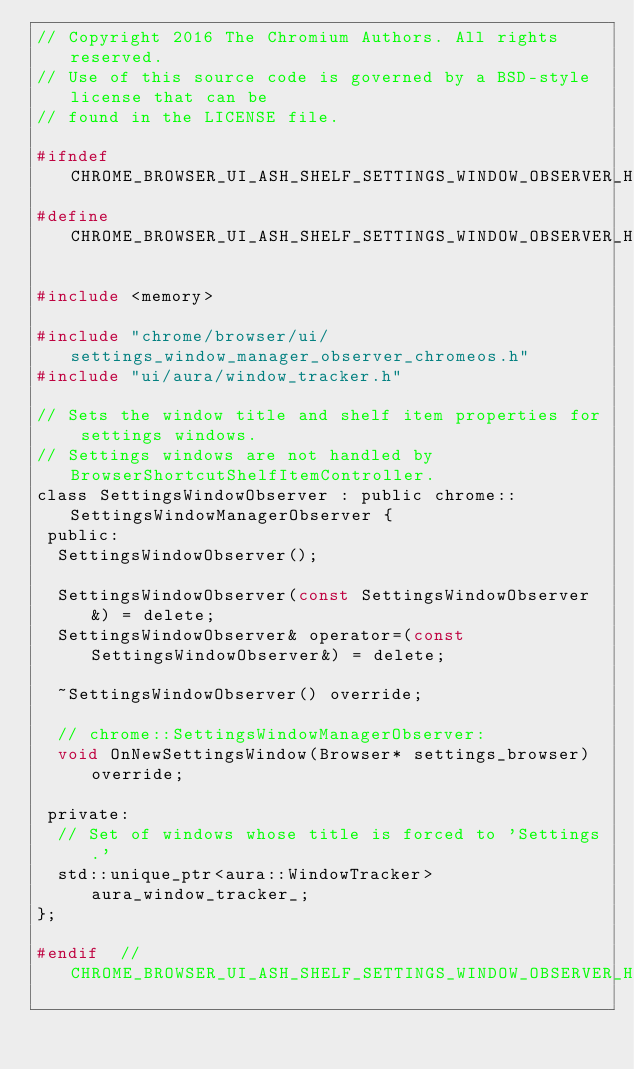Convert code to text. <code><loc_0><loc_0><loc_500><loc_500><_C_>// Copyright 2016 The Chromium Authors. All rights reserved.
// Use of this source code is governed by a BSD-style license that can be
// found in the LICENSE file.

#ifndef CHROME_BROWSER_UI_ASH_SHELF_SETTINGS_WINDOW_OBSERVER_H_
#define CHROME_BROWSER_UI_ASH_SHELF_SETTINGS_WINDOW_OBSERVER_H_

#include <memory>

#include "chrome/browser/ui/settings_window_manager_observer_chromeos.h"
#include "ui/aura/window_tracker.h"

// Sets the window title and shelf item properties for settings windows.
// Settings windows are not handled by BrowserShortcutShelfItemController.
class SettingsWindowObserver : public chrome::SettingsWindowManagerObserver {
 public:
  SettingsWindowObserver();

  SettingsWindowObserver(const SettingsWindowObserver&) = delete;
  SettingsWindowObserver& operator=(const SettingsWindowObserver&) = delete;

  ~SettingsWindowObserver() override;

  // chrome::SettingsWindowManagerObserver:
  void OnNewSettingsWindow(Browser* settings_browser) override;

 private:
  // Set of windows whose title is forced to 'Settings.'
  std::unique_ptr<aura::WindowTracker> aura_window_tracker_;
};

#endif  // CHROME_BROWSER_UI_ASH_SHELF_SETTINGS_WINDOW_OBSERVER_H_
</code> 